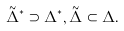<formula> <loc_0><loc_0><loc_500><loc_500>\tilde { \Delta } ^ { * } \supset \Delta ^ { * } , \tilde { \Delta } \subset \Delta .</formula> 